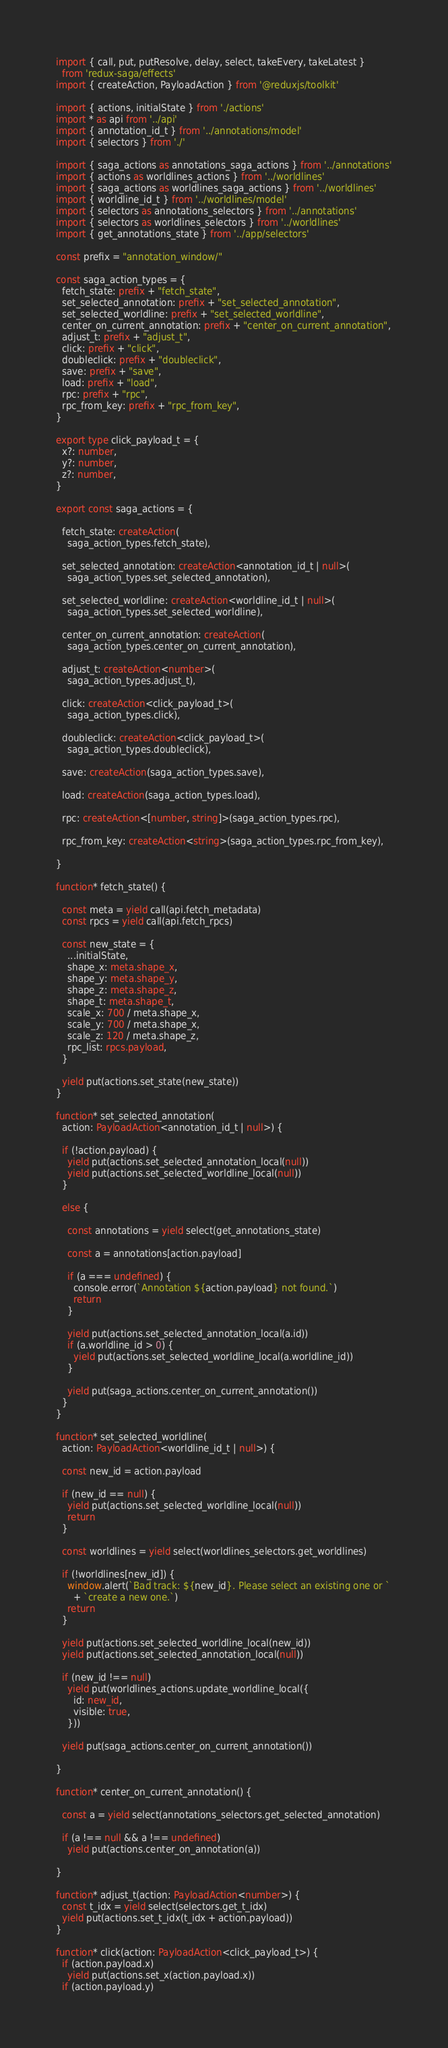<code> <loc_0><loc_0><loc_500><loc_500><_TypeScript_>import { call, put, putResolve, delay, select, takeEvery, takeLatest }
  from 'redux-saga/effects'
import { createAction, PayloadAction } from '@reduxjs/toolkit'

import { actions, initialState } from './actions'
import * as api from '../api'
import { annotation_id_t } from '../annotations/model'
import { selectors } from './'

import { saga_actions as annotations_saga_actions } from '../annotations'
import { actions as worldlines_actions } from '../worldlines'
import { saga_actions as worldlines_saga_actions } from '../worldlines'
import { worldline_id_t } from '../worldlines/model'
import { selectors as annotations_selectors } from '../annotations'
import { selectors as worldlines_selectors } from '../worldlines'
import { get_annotations_state } from '../app/selectors'

const prefix = "annotation_window/"

const saga_action_types = {
  fetch_state: prefix + "fetch_state",
  set_selected_annotation: prefix + "set_selected_annotation",
  set_selected_worldline: prefix + "set_selected_worldline",
  center_on_current_annotation: prefix + "center_on_current_annotation",
  adjust_t: prefix + "adjust_t",
  click: prefix + "click",
  doubleclick: prefix + "doubleclick",
  save: prefix + "save",
  load: prefix + "load",
  rpc: prefix + "rpc",
  rpc_from_key: prefix + "rpc_from_key",
}

export type click_payload_t = {
  x?: number,
  y?: number,
  z?: number,
}

export const saga_actions = {

  fetch_state: createAction(
    saga_action_types.fetch_state),

  set_selected_annotation: createAction<annotation_id_t | null>(
    saga_action_types.set_selected_annotation),

  set_selected_worldline: createAction<worldline_id_t | null>(
    saga_action_types.set_selected_worldline),

  center_on_current_annotation: createAction(
    saga_action_types.center_on_current_annotation),

  adjust_t: createAction<number>(
    saga_action_types.adjust_t),

  click: createAction<click_payload_t>(
    saga_action_types.click),

  doubleclick: createAction<click_payload_t>(
    saga_action_types.doubleclick),

  save: createAction(saga_action_types.save),

  load: createAction(saga_action_types.load),

  rpc: createAction<[number, string]>(saga_action_types.rpc),

  rpc_from_key: createAction<string>(saga_action_types.rpc_from_key),

}

function* fetch_state() {

  const meta = yield call(api.fetch_metadata)
  const rpcs = yield call(api.fetch_rpcs)

  const new_state = {
    ...initialState,
    shape_x: meta.shape_x,
    shape_y: meta.shape_y,
    shape_z: meta.shape_z,
    shape_t: meta.shape_t,
    scale_x: 700 / meta.shape_x,
    scale_y: 700 / meta.shape_x,
    scale_z: 120 / meta.shape_z,
    rpc_list: rpcs.payload,
  }

  yield put(actions.set_state(new_state))
}

function* set_selected_annotation(
  action: PayloadAction<annotation_id_t | null>) {

  if (!action.payload) {
    yield put(actions.set_selected_annotation_local(null))
    yield put(actions.set_selected_worldline_local(null))
  }

  else {

    const annotations = yield select(get_annotations_state)

    const a = annotations[action.payload]

    if (a === undefined) {
      console.error(`Annotation ${action.payload} not found.`)
      return
    }

    yield put(actions.set_selected_annotation_local(a.id))
    if (a.worldline_id > 0) {
      yield put(actions.set_selected_worldline_local(a.worldline_id))
    }

    yield put(saga_actions.center_on_current_annotation())
  }
}

function* set_selected_worldline(
  action: PayloadAction<worldline_id_t | null>) {

  const new_id = action.payload

  if (new_id == null) {
    yield put(actions.set_selected_worldline_local(null))
    return
  }

  const worldlines = yield select(worldlines_selectors.get_worldlines)

  if (!worldlines[new_id]) {
    window.alert(`Bad track: ${new_id}. Please select an existing one or `
      + `create a new one.`)
    return
  }

  yield put(actions.set_selected_worldline_local(new_id))
  yield put(actions.set_selected_annotation_local(null))

  if (new_id !== null)
    yield put(worldlines_actions.update_worldline_local({
      id: new_id,
      visible: true,
    }))

  yield put(saga_actions.center_on_current_annotation())

}

function* center_on_current_annotation() {

  const a = yield select(annotations_selectors.get_selected_annotation)

  if (a !== null && a !== undefined)
    yield put(actions.center_on_annotation(a))

}

function* adjust_t(action: PayloadAction<number>) {
  const t_idx = yield select(selectors.get_t_idx)
  yield put(actions.set_t_idx(t_idx + action.payload))
}

function* click(action: PayloadAction<click_payload_t>) {
  if (action.payload.x)
    yield put(actions.set_x(action.payload.x))
  if (action.payload.y)</code> 